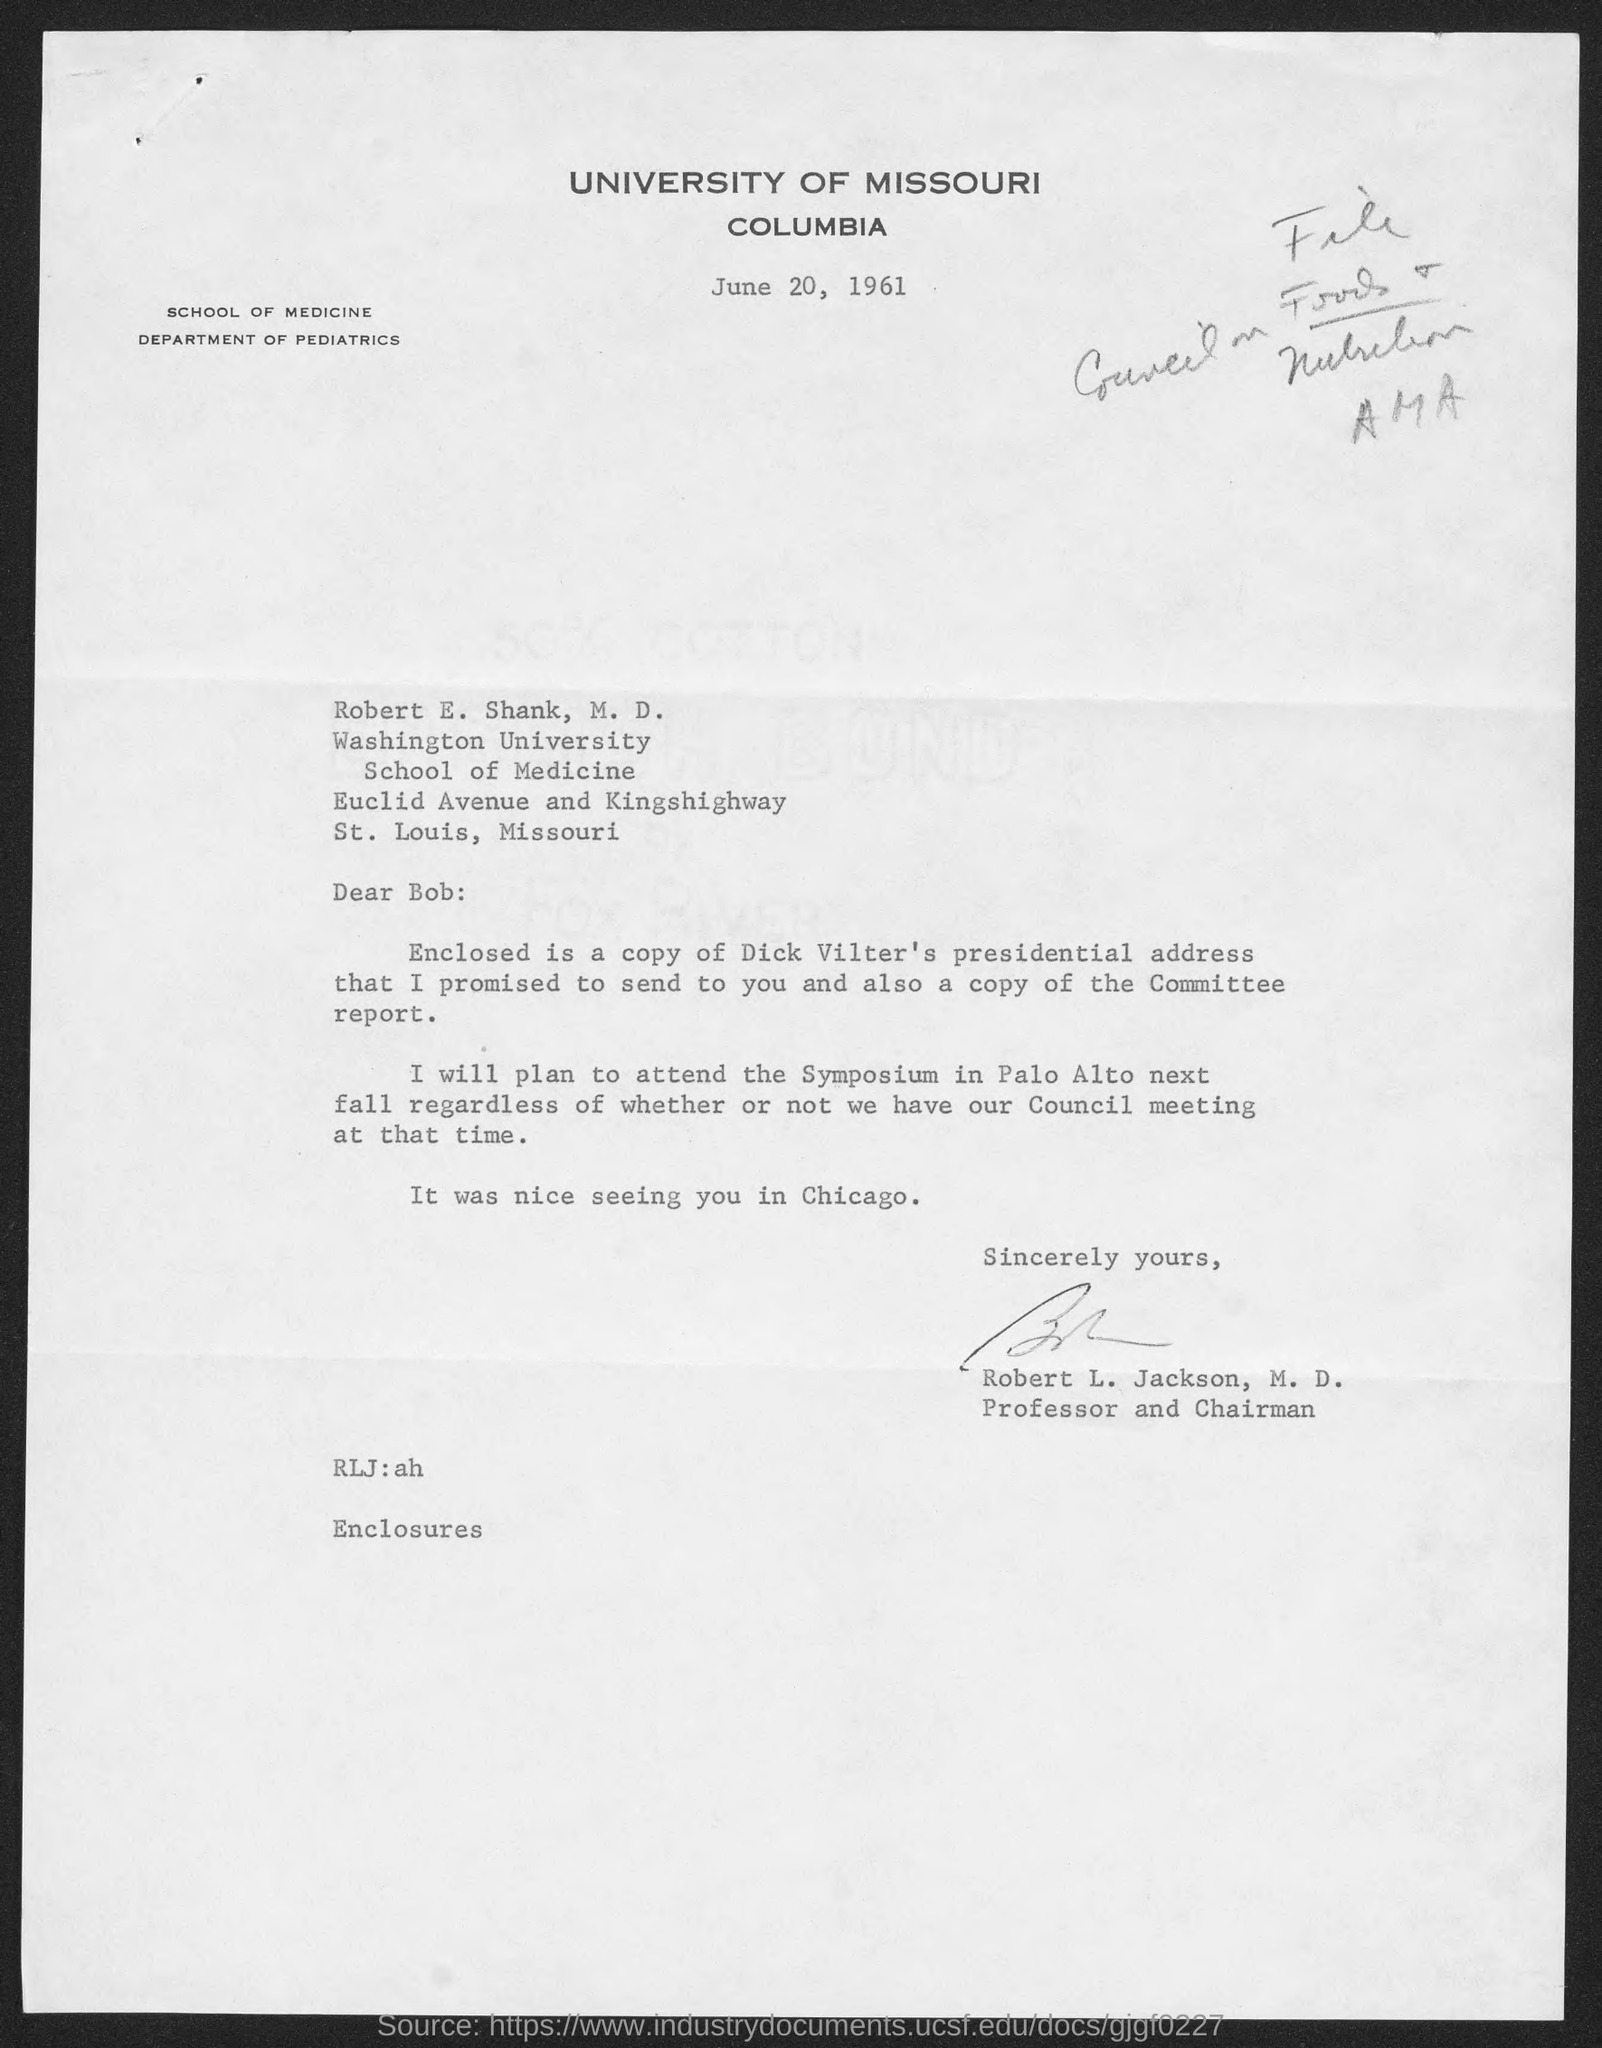Point out several critical features in this image. The University of Missouri is located in Columbia. 